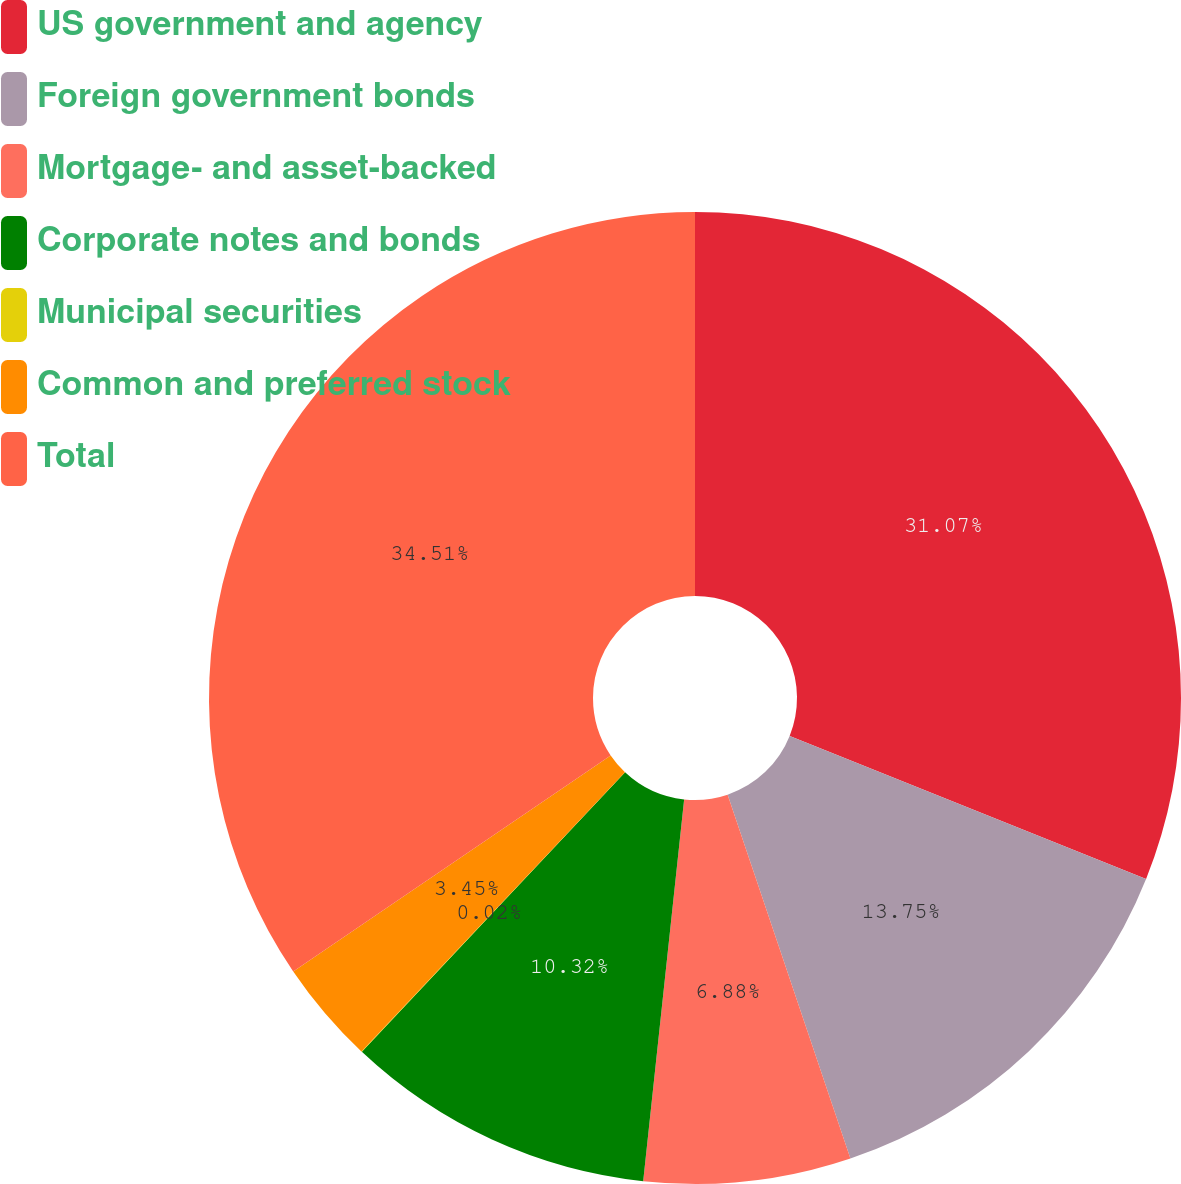Convert chart to OTSL. <chart><loc_0><loc_0><loc_500><loc_500><pie_chart><fcel>US government and agency<fcel>Foreign government bonds<fcel>Mortgage- and asset-backed<fcel>Corporate notes and bonds<fcel>Municipal securities<fcel>Common and preferred stock<fcel>Total<nl><fcel>31.07%<fcel>13.75%<fcel>6.88%<fcel>10.32%<fcel>0.02%<fcel>3.45%<fcel>34.51%<nl></chart> 